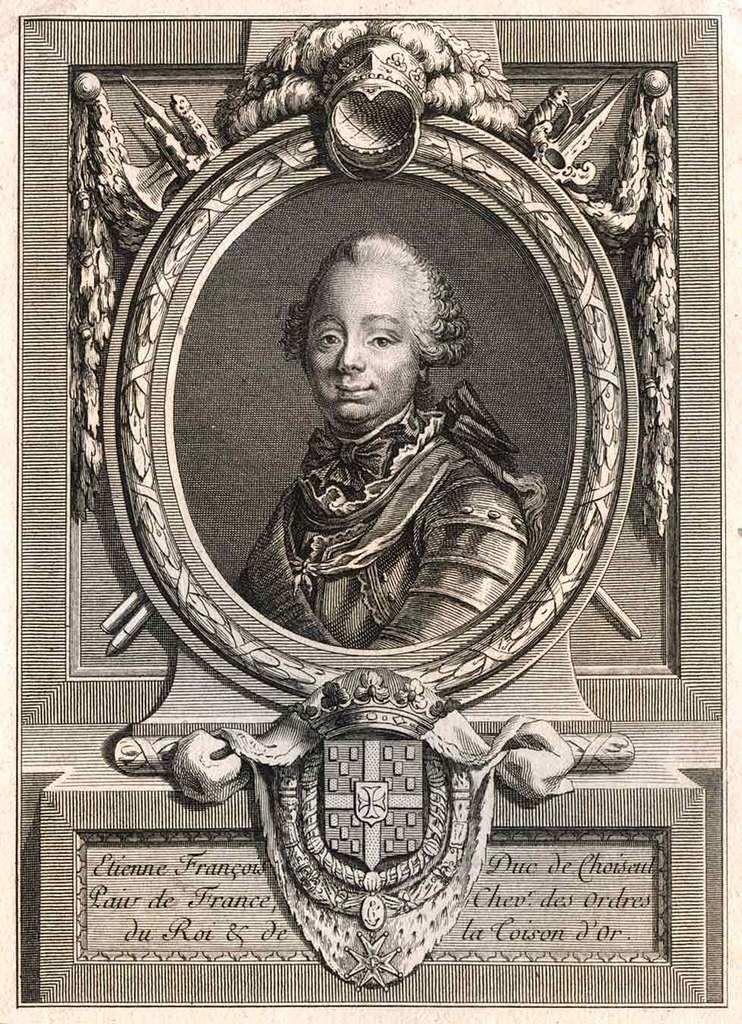What language is the text in below the picture?
Keep it short and to the point. Unanswerable. 